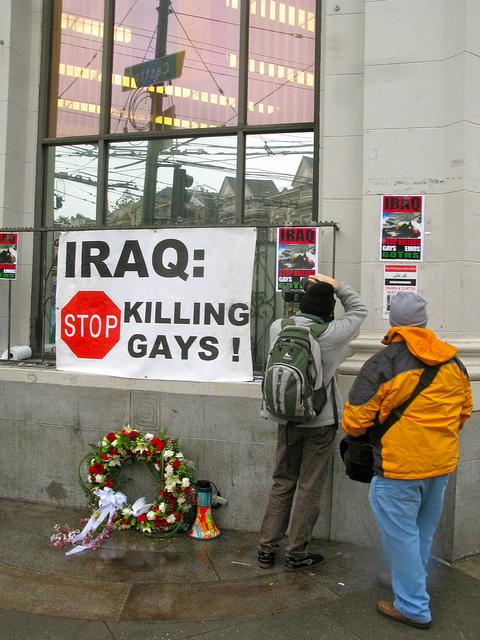What type of death might the Wreath commemorate? murder 